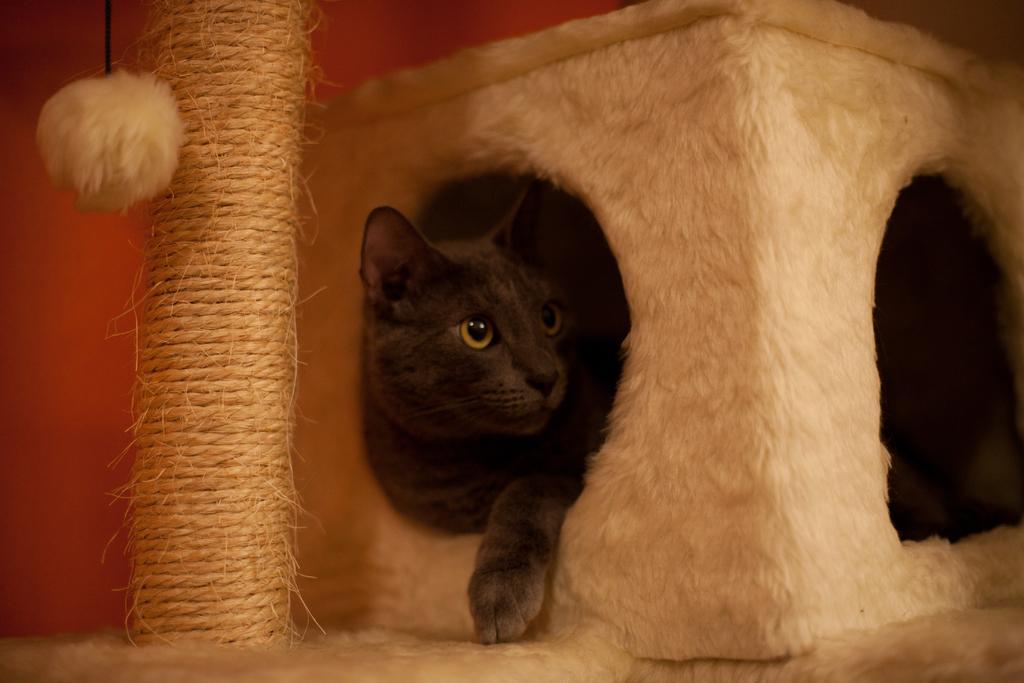How would you summarize this image in a sentence or two? In the image we can see a box, in the box there is a cat. Behind the box there is wall. 